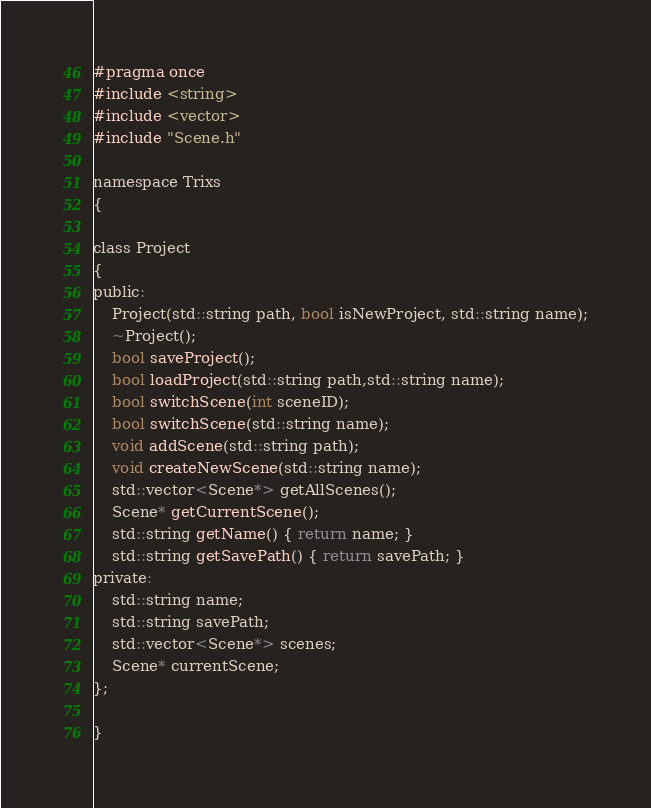<code> <loc_0><loc_0><loc_500><loc_500><_C_>#pragma once
#include <string>
#include <vector>
#include "Scene.h"

namespace Trixs
{

class Project
{
public:
	Project(std::string path, bool isNewProject, std::string name);
	~Project();
	bool saveProject();
	bool loadProject(std::string path,std::string name);
	bool switchScene(int sceneID);
	bool switchScene(std::string name);
	void addScene(std::string path);
	void createNewScene(std::string name);
	std::vector<Scene*> getAllScenes();
	Scene* getCurrentScene();
	std::string getName() { return name; }
	std::string getSavePath() { return savePath; }
private:
	std::string name;
	std::string savePath;
	std::vector<Scene*> scenes;
	Scene* currentScene;
};

}
</code> 